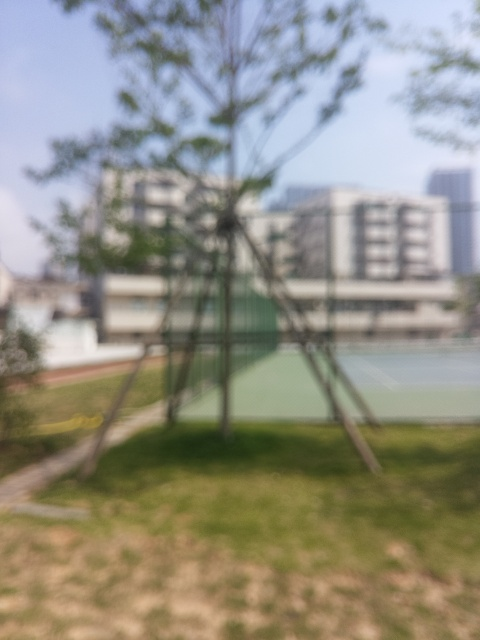Can you guess the time of day or weather conditions in the image? The brightness and absence of shadows in the blurred image could imply an overcast sky or the time being close to midday when the sun is high, resulting in diffused lighting. However, without clear visual cues, this is speculative. 